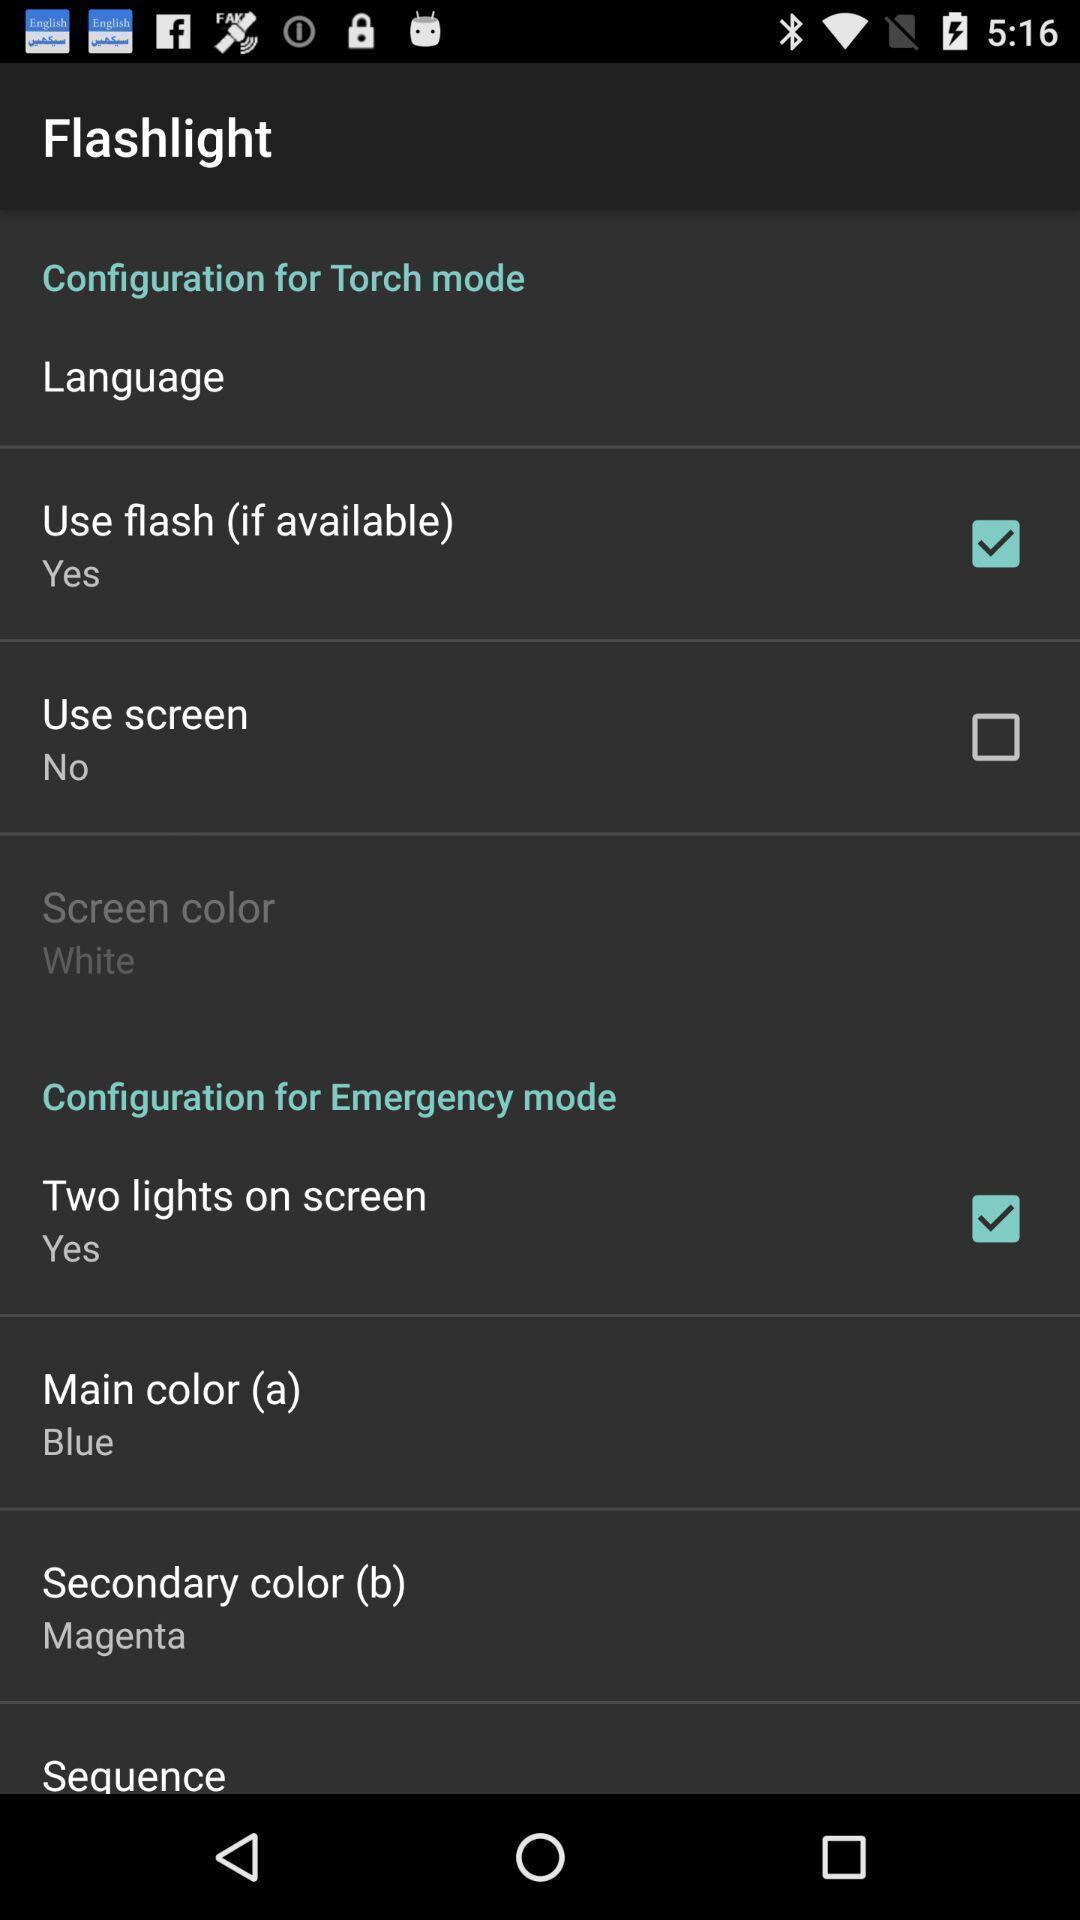Provide a detailed account of this screenshot. Page showing flashlight setting options. 